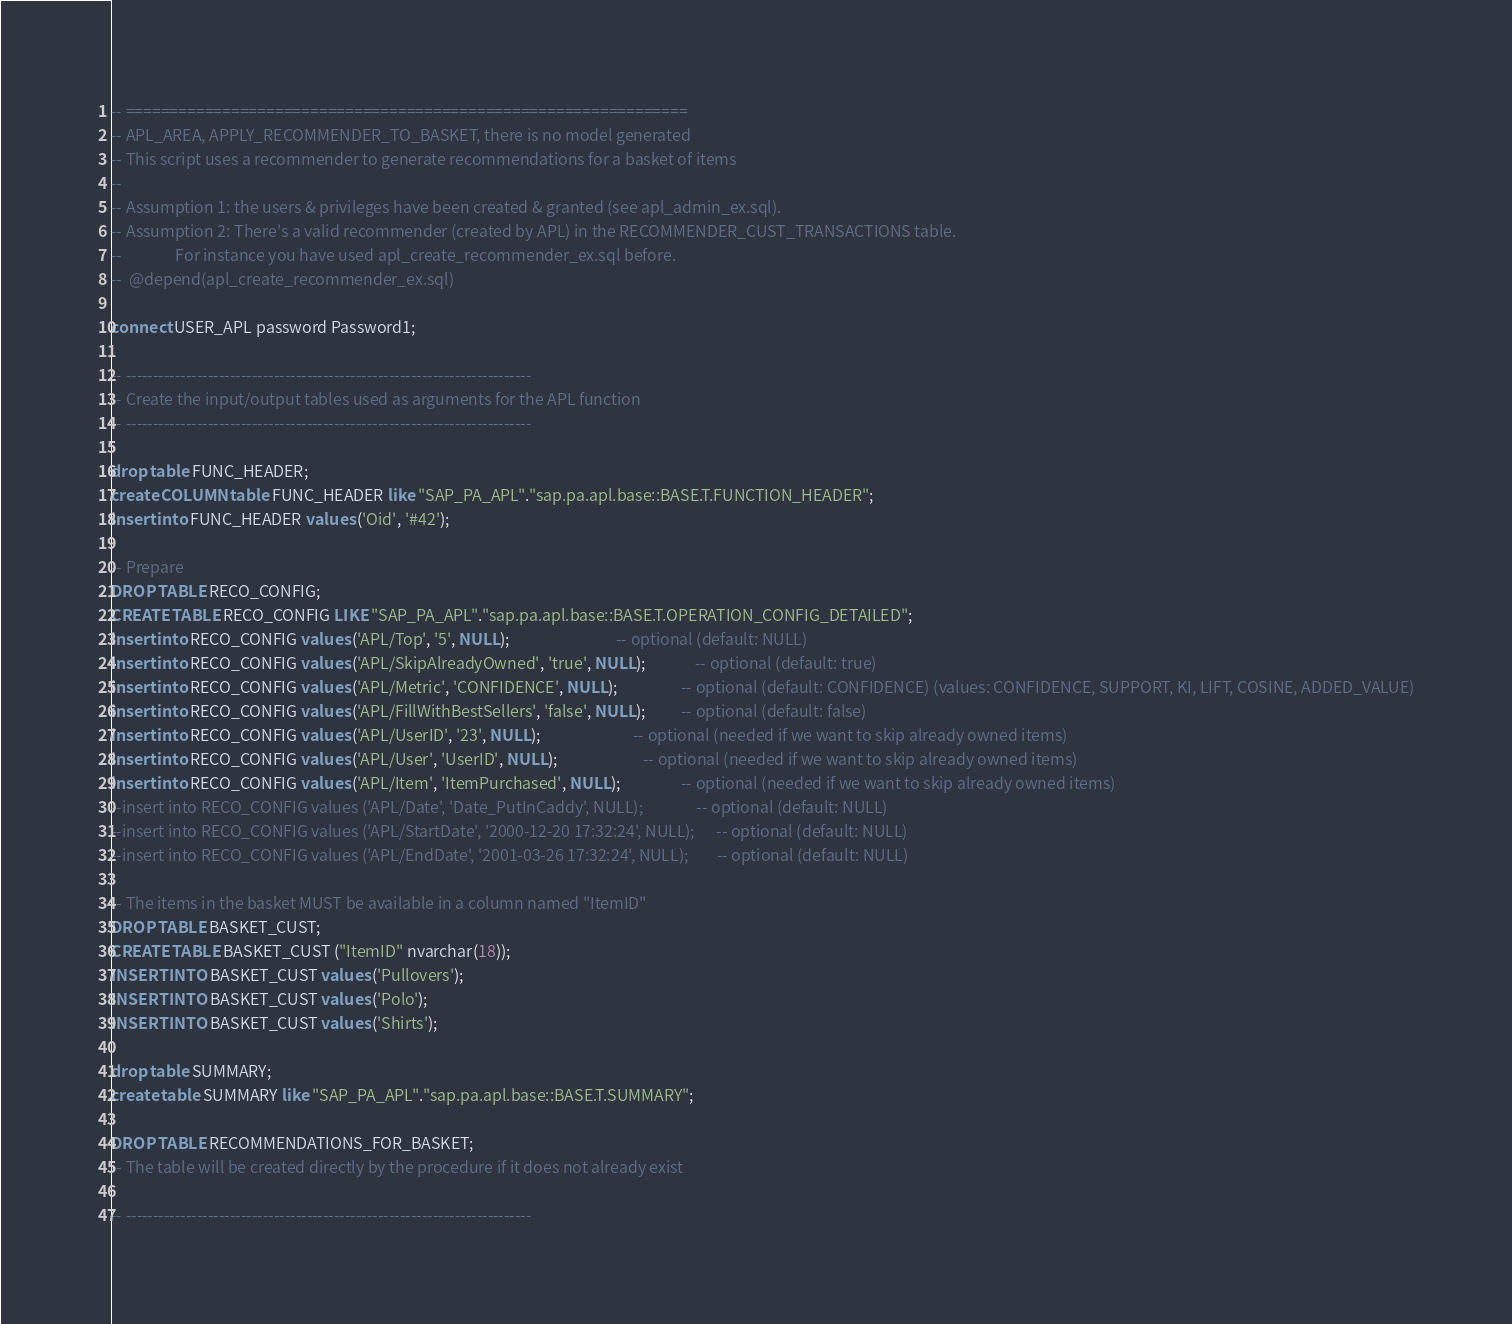<code> <loc_0><loc_0><loc_500><loc_500><_SQL_>-- ================================================================
-- APL_AREA, APPLY_RECOMMENDER_TO_BASKET, there is no model generated
-- This script uses a recommender to generate recommendations for a basket of items
--
-- Assumption 1: the users & privileges have been created & granted (see apl_admin_ex.sql).
-- Assumption 2: There's a valid recommender (created by APL) in the RECOMMENDER_CUST_TRANSACTIONS table. 
--               For instance you have used apl_create_recommender_ex.sql before.
--  @depend(apl_create_recommender_ex.sql)

connect USER_APL password Password1;

-- --------------------------------------------------------------------------
-- Create the input/output tables used as arguments for the APL function
-- --------------------------------------------------------------------------

drop table FUNC_HEADER;
create COLUMN table FUNC_HEADER like "SAP_PA_APL"."sap.pa.apl.base::BASE.T.FUNCTION_HEADER";
insert into FUNC_HEADER values ('Oid', '#42');

-- Prepare
DROP TABLE RECO_CONFIG;
CREATE TABLE RECO_CONFIG LIKE "SAP_PA_APL"."sap.pa.apl.base::BASE.T.OPERATION_CONFIG_DETAILED";
insert into RECO_CONFIG values ('APL/Top', '5', NULL);                              -- optional (default: NULL)
insert into RECO_CONFIG values ('APL/SkipAlreadyOwned', 'true', NULL);              -- optional (default: true)
insert into RECO_CONFIG values ('APL/Metric', 'CONFIDENCE', NULL);                  -- optional (default: CONFIDENCE) (values: CONFIDENCE, SUPPORT, KI, LIFT, COSINE, ADDED_VALUE)
insert into RECO_CONFIG values ('APL/FillWithBestSellers', 'false', NULL);          -- optional (default: false)
insert into RECO_CONFIG values ('APL/UserID', '23', NULL);                          -- optional (needed if we want to skip already owned items)
insert into RECO_CONFIG values ('APL/User', 'UserID', NULL);                        -- optional (needed if we want to skip already owned items)
insert into RECO_CONFIG values ('APL/Item', 'ItemPurchased', NULL);                 -- optional (needed if we want to skip already owned items)
--insert into RECO_CONFIG values ('APL/Date', 'Date_PutInCaddy', NULL);               -- optional (default: NULL)
--insert into RECO_CONFIG values ('APL/StartDate', '2000-12-20 17:32:24', NULL);      -- optional (default: NULL)
--insert into RECO_CONFIG values ('APL/EndDate', '2001-03-26 17:32:24', NULL);        -- optional (default: NULL)

-- The items in the basket MUST be available in a column named "ItemID"
DROP TABLE BASKET_CUST;
CREATE TABLE BASKET_CUST ("ItemID" nvarchar(18));
INSERT INTO BASKET_CUST values ('Pullovers');
INSERT INTO BASKET_CUST values ('Polo');
INSERT INTO BASKET_CUST values ('Shirts');

drop table SUMMARY;
create table SUMMARY like "SAP_PA_APL"."sap.pa.apl.base::BASE.T.SUMMARY";

DROP TABLE RECOMMENDATIONS_FOR_BASKET;
-- The table will be created directly by the procedure if it does not already exist

-- --------------------------------------------------------------------------</code> 